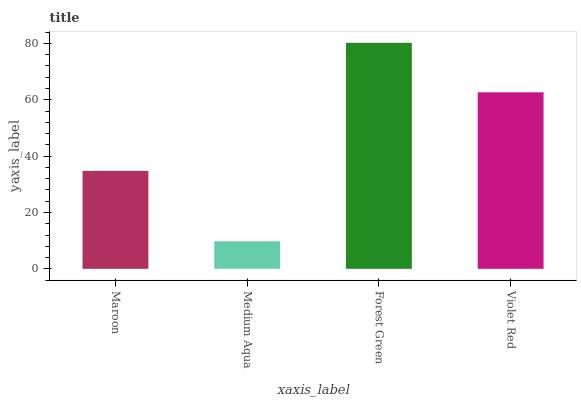Is Medium Aqua the minimum?
Answer yes or no. Yes. Is Forest Green the maximum?
Answer yes or no. Yes. Is Forest Green the minimum?
Answer yes or no. No. Is Medium Aqua the maximum?
Answer yes or no. No. Is Forest Green greater than Medium Aqua?
Answer yes or no. Yes. Is Medium Aqua less than Forest Green?
Answer yes or no. Yes. Is Medium Aqua greater than Forest Green?
Answer yes or no. No. Is Forest Green less than Medium Aqua?
Answer yes or no. No. Is Violet Red the high median?
Answer yes or no. Yes. Is Maroon the low median?
Answer yes or no. Yes. Is Medium Aqua the high median?
Answer yes or no. No. Is Medium Aqua the low median?
Answer yes or no. No. 